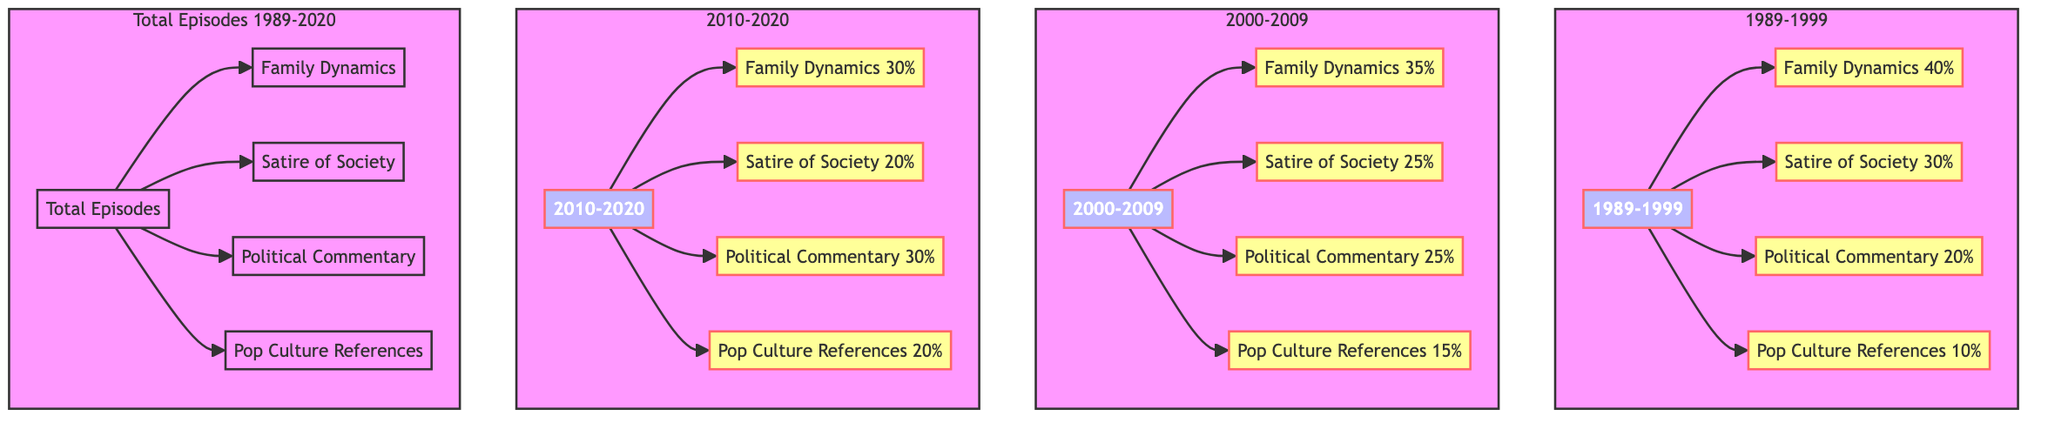What percentage of themes in the 1989-1999 era focus on Family Dynamics? In the 1989-1999 section of the diagram, Family Dynamics is represented with a 40% portion, which is indicated by the node connected to the era.
Answer: 40% Which theme had the lowest representation in the 2000-2009 era? Looking at the 2000-2009 era, Pop Culture References is indicated with a 15% portion, which is the smallest percentage compared to the other themes represented.
Answer: Pop Culture References What is the combined percentage of Political Commentary across all three eras? By examining each era, we identify Political Commentary as 20% in 1989-1999, 25% in 2000-2009, and 30% in 2010-2020. Adding these percentages gives: 20 + 25 + 30 = 75%.
Answer: 75% In the 2010-2020 era, what percentage of themes are dedicated to Satire of Society? From the 2010-2020 section, the representation for Satire of Society is shown to be 20%, as indicated by its corresponding node.
Answer: 20% How many total themes are presented in the diagram? The diagram lists four distinct themes: Family Dynamics, Satire of Society, Political Commentary, and Pop Culture References. Therefore, the total number of themes is four.
Answer: 4 Which era has the highest representation of Satire of Society? Comparing the figures for Satire of Society: 30% in 1989-1999, 25% in 2000-2009, and 20% in 2010-2020, the highest percentage appears in the 1989-1999 era.
Answer: 1989-1999 What is the percentage of Family Dynamics in the Total Episodes section of the diagram? The Total Episodes node connects to Family Dynamics but does not specify a percentage; however, the breakdown provided earlier indicates that Family Dynamics consistently holds a significant proportion across all eras.
Answer: Not specified Which era saw an increase in the percentage of Political Commentary compared to the previous era? By charting the percentages: 20% in 1989-1999, 25% in 2000-2009, and then 30% in 2010-2020, it is evident that each subsequent era increases the percentage for Political Commentary.
Answer: 2000-2009 